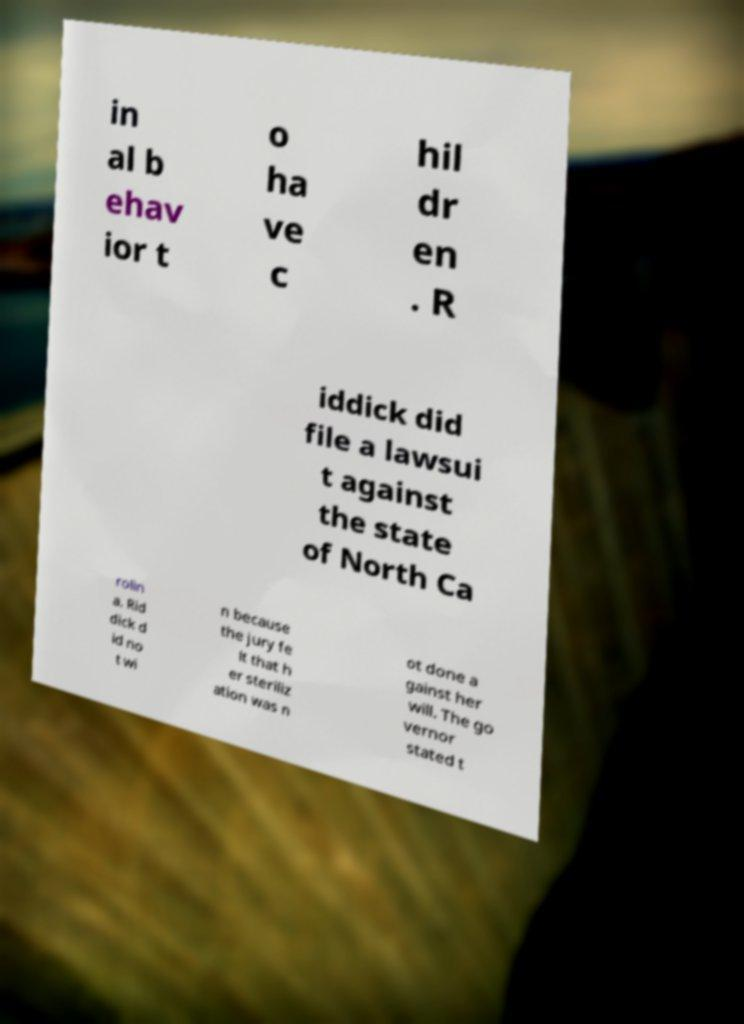Could you assist in decoding the text presented in this image and type it out clearly? in al b ehav ior t o ha ve c hil dr en . R iddick did file a lawsui t against the state of North Ca rolin a. Rid dick d id no t wi n because the jury fe lt that h er steriliz ation was n ot done a gainst her will. The go vernor stated t 